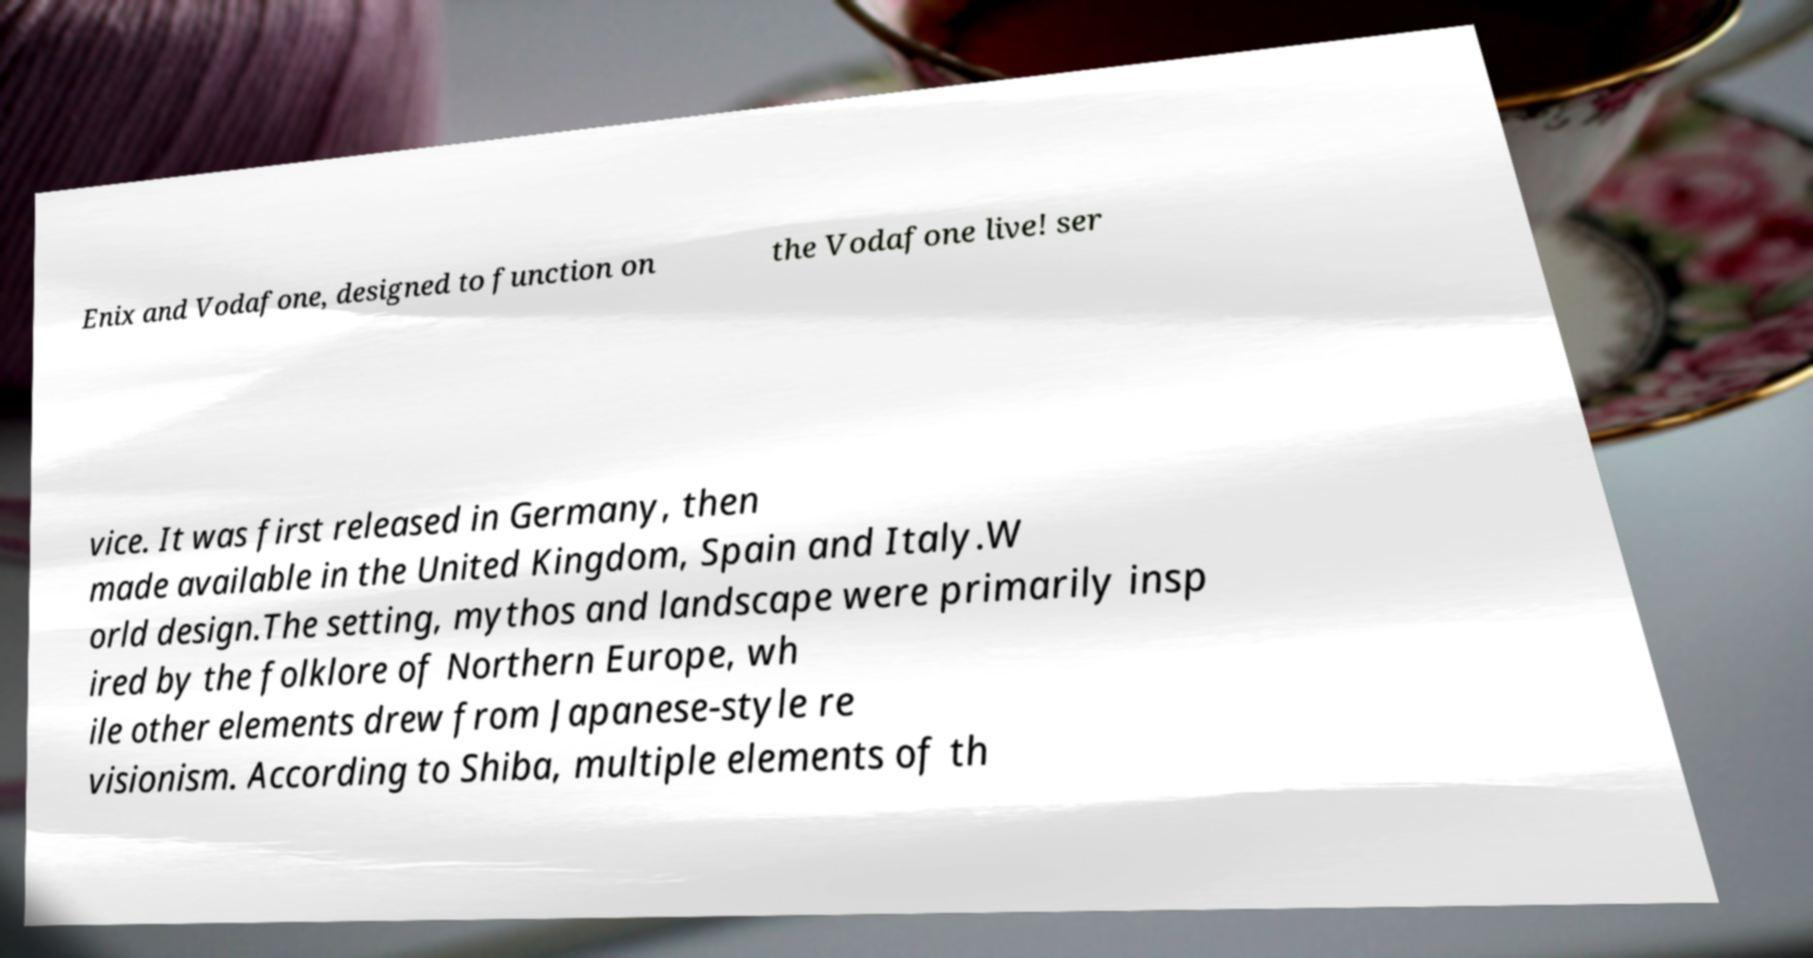There's text embedded in this image that I need extracted. Can you transcribe it verbatim? Enix and Vodafone, designed to function on the Vodafone live! ser vice. It was first released in Germany, then made available in the United Kingdom, Spain and Italy.W orld design.The setting, mythos and landscape were primarily insp ired by the folklore of Northern Europe, wh ile other elements drew from Japanese-style re visionism. According to Shiba, multiple elements of th 